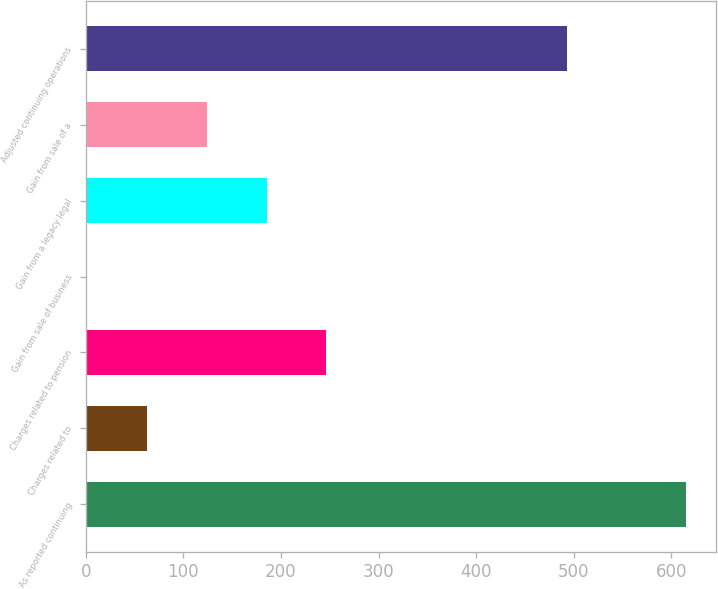<chart> <loc_0><loc_0><loc_500><loc_500><bar_chart><fcel>As reported continuing<fcel>Charges related to<fcel>Charges related to pension<fcel>Gain from sale of business<fcel>Gain from a legacy legal<fcel>Gain from sale of a<fcel>Adjusted continuing operations<nl><fcel>615<fcel>62.4<fcel>246.6<fcel>1<fcel>185.2<fcel>123.8<fcel>493<nl></chart> 